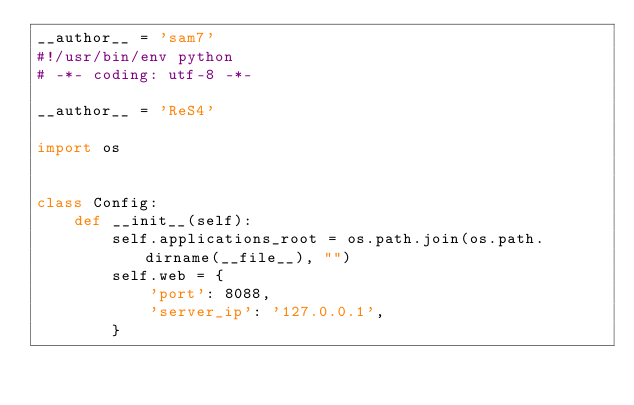Convert code to text. <code><loc_0><loc_0><loc_500><loc_500><_Python_>__author__ = 'sam7'
#!/usr/bin/env python
# -*- coding: utf-8 -*-

__author__ = 'ReS4'

import os


class Config:
    def __init__(self):
        self.applications_root = os.path.join(os.path.dirname(__file__), "")
        self.web = {
            'port': 8088,
            'server_ip': '127.0.0.1',
        }</code> 